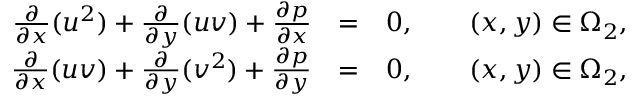Convert formula to latex. <formula><loc_0><loc_0><loc_500><loc_500>\begin{array} { r l r } { \frac { \partial } { \partial x } ( u ^ { 2 } ) + \frac { \partial } { \partial y } ( u v ) + \frac { \partial p } { \partial x } } & { = } & { 0 , \quad ( x , y ) \in \Omega _ { 2 } , } \\ { \frac { \partial } { \partial x } ( u v ) + \frac { \partial } { \partial y } ( v ^ { 2 } ) + \frac { \partial p } { \partial y } } & { = } & { 0 , \quad ( x , y ) \in \Omega _ { 2 } , } \end{array}</formula> 